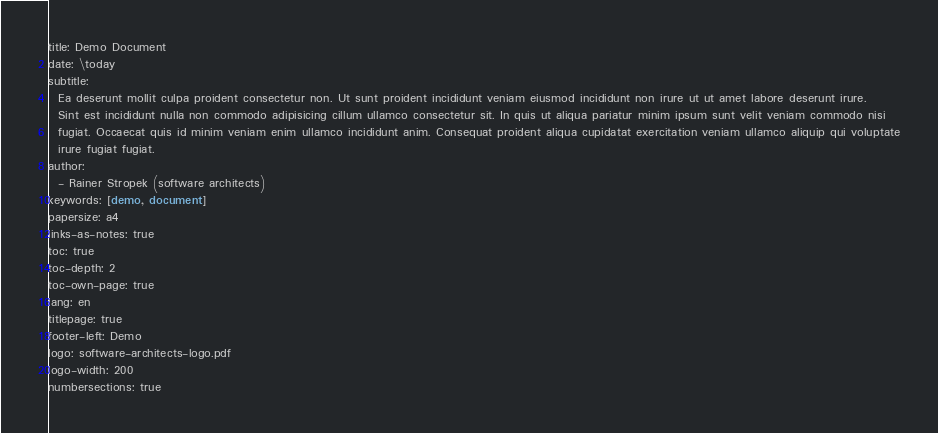Convert code to text. <code><loc_0><loc_0><loc_500><loc_500><_YAML_>title: Demo Document
date: \today
subtitle:
  Ea deserunt mollit culpa proident consectetur non. Ut sunt proident incididunt veniam eiusmod incididunt non irure ut ut amet labore deserunt irure.
  Sint est incididunt nulla non commodo adipisicing cillum ullamco consectetur sit. In quis ut aliqua pariatur minim ipsum sunt velit veniam commodo nisi
  fugiat. Occaecat quis id minim veniam enim ullamco incididunt anim. Consequat proident aliqua cupidatat exercitation veniam ullamco aliquip qui voluptate
  irure fugiat fugiat.
author:
  - Rainer Stropek (software architects)
keywords: [demo, document]
papersize: a4
links-as-notes: true
toc: true
toc-depth: 2
toc-own-page: true
lang: en
titlepage: true
footer-left: Demo
logo: software-architects-logo.pdf
logo-width: 200
numbersections: true
</code> 